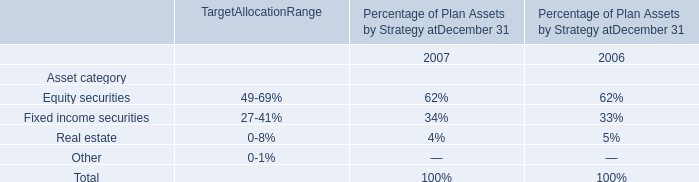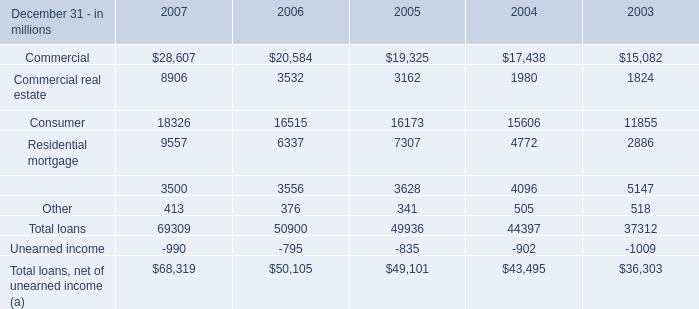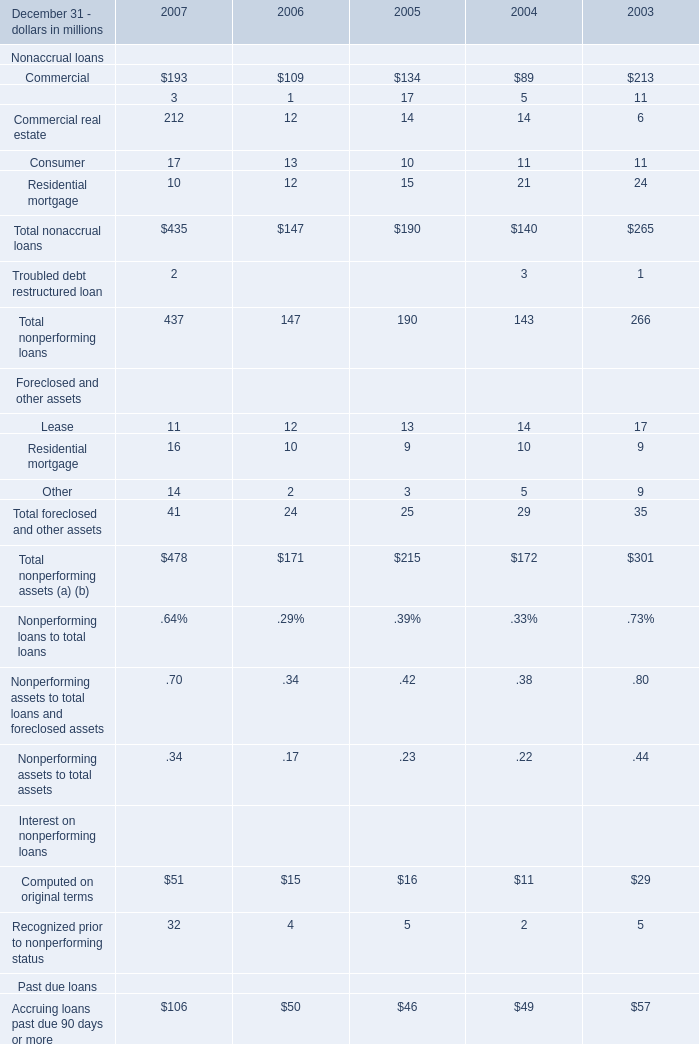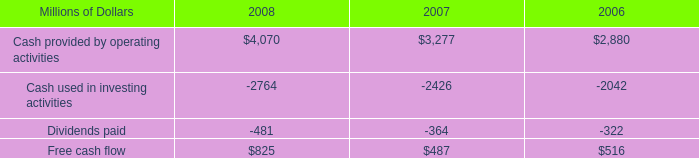What was the average value of the Total nonaccrual loans in the years where Nonaccrual loans:Commercial is positive? (in million) 
Computations: (((((435 + 147) + 190) + 140) + 265) / 5)
Answer: 235.4. 